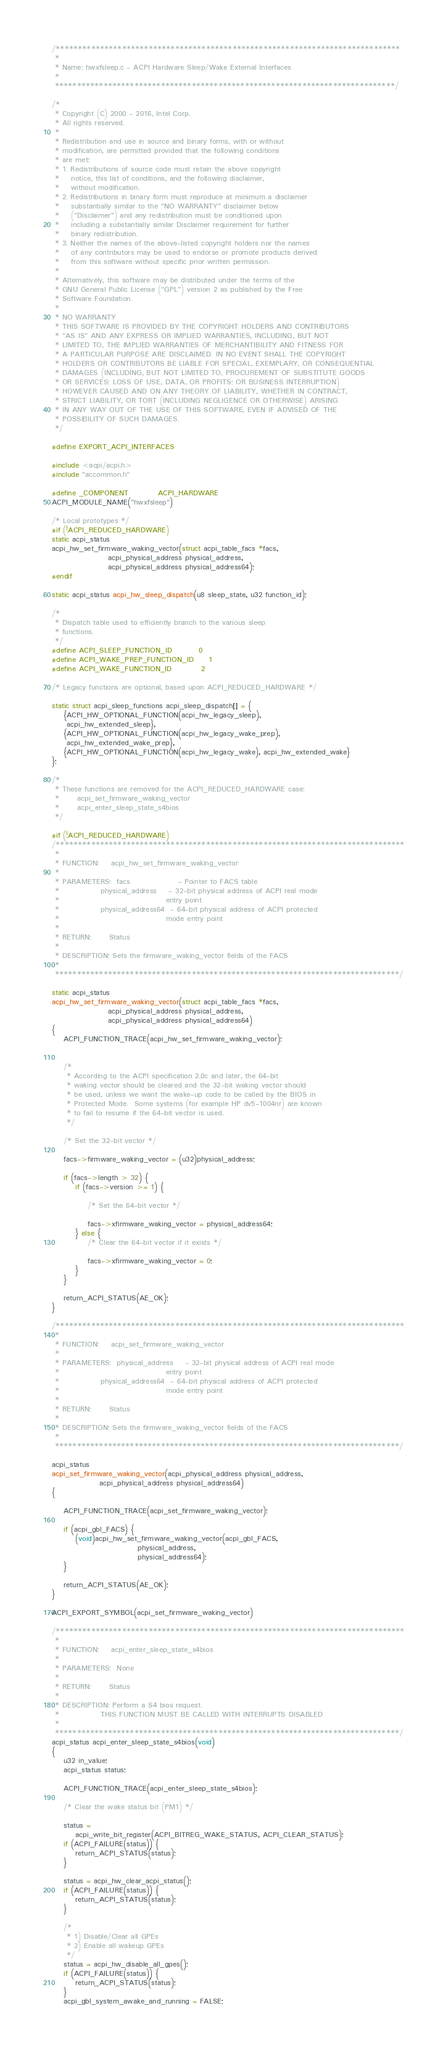<code> <loc_0><loc_0><loc_500><loc_500><_C_>/******************************************************************************
 *
 * Name: hwxfsleep.c - ACPI Hardware Sleep/Wake External Interfaces
 *
 *****************************************************************************/

/*
 * Copyright (C) 2000 - 2016, Intel Corp.
 * All rights reserved.
 *
 * Redistribution and use in source and binary forms, with or without
 * modification, are permitted provided that the following conditions
 * are met:
 * 1. Redistributions of source code must retain the above copyright
 *    notice, this list of conditions, and the following disclaimer,
 *    without modification.
 * 2. Redistributions in binary form must reproduce at minimum a disclaimer
 *    substantially similar to the "NO WARRANTY" disclaimer below
 *    ("Disclaimer") and any redistribution must be conditioned upon
 *    including a substantially similar Disclaimer requirement for further
 *    binary redistribution.
 * 3. Neither the names of the above-listed copyright holders nor the names
 *    of any contributors may be used to endorse or promote products derived
 *    from this software without specific prior written permission.
 *
 * Alternatively, this software may be distributed under the terms of the
 * GNU General Public License ("GPL") version 2 as published by the Free
 * Software Foundation.
 *
 * NO WARRANTY
 * THIS SOFTWARE IS PROVIDED BY THE COPYRIGHT HOLDERS AND CONTRIBUTORS
 * "AS IS" AND ANY EXPRESS OR IMPLIED WARRANTIES, INCLUDING, BUT NOT
 * LIMITED TO, THE IMPLIED WARRANTIES OF MERCHANTIBILITY AND FITNESS FOR
 * A PARTICULAR PURPOSE ARE DISCLAIMED. IN NO EVENT SHALL THE COPYRIGHT
 * HOLDERS OR CONTRIBUTORS BE LIABLE FOR SPECIAL, EXEMPLARY, OR CONSEQUENTIAL
 * DAMAGES (INCLUDING, BUT NOT LIMITED TO, PROCUREMENT OF SUBSTITUTE GOODS
 * OR SERVICES; LOSS OF USE, DATA, OR PROFITS; OR BUSINESS INTERRUPTION)
 * HOWEVER CAUSED AND ON ANY THEORY OF LIABILITY, WHETHER IN CONTRACT,
 * STRICT LIABILITY, OR TORT (INCLUDING NEGLIGENCE OR OTHERWISE) ARISING
 * IN ANY WAY OUT OF THE USE OF THIS SOFTWARE, EVEN IF ADVISED OF THE
 * POSSIBILITY OF SUCH DAMAGES.
 */

#define EXPORT_ACPI_INTERFACES

#include <acpi/acpi.h>
#include "accommon.h"

#define _COMPONENT          ACPI_HARDWARE
ACPI_MODULE_NAME("hwxfsleep")

/* Local prototypes */
#if (!ACPI_REDUCED_HARDWARE)
static acpi_status
acpi_hw_set_firmware_waking_vector(struct acpi_table_facs *facs,
				   acpi_physical_address physical_address,
				   acpi_physical_address physical_address64);
#endif

static acpi_status acpi_hw_sleep_dispatch(u8 sleep_state, u32 function_id);

/*
 * Dispatch table used to efficiently branch to the various sleep
 * functions.
 */
#define ACPI_SLEEP_FUNCTION_ID         0
#define ACPI_WAKE_PREP_FUNCTION_ID     1
#define ACPI_WAKE_FUNCTION_ID          2

/* Legacy functions are optional, based upon ACPI_REDUCED_HARDWARE */

static struct acpi_sleep_functions acpi_sleep_dispatch[] = {
	{ACPI_HW_OPTIONAL_FUNCTION(acpi_hw_legacy_sleep),
	 acpi_hw_extended_sleep},
	{ACPI_HW_OPTIONAL_FUNCTION(acpi_hw_legacy_wake_prep),
	 acpi_hw_extended_wake_prep},
	{ACPI_HW_OPTIONAL_FUNCTION(acpi_hw_legacy_wake), acpi_hw_extended_wake}
};

/*
 * These functions are removed for the ACPI_REDUCED_HARDWARE case:
 *      acpi_set_firmware_waking_vector
 *      acpi_enter_sleep_state_s4bios
 */

#if (!ACPI_REDUCED_HARDWARE)
/*******************************************************************************
 *
 * FUNCTION:    acpi_hw_set_firmware_waking_vector
 *
 * PARAMETERS:  facs                - Pointer to FACS table
 *              physical_address    - 32-bit physical address of ACPI real mode
 *                                    entry point
 *              physical_address64  - 64-bit physical address of ACPI protected
 *                                    mode entry point
 *
 * RETURN:      Status
 *
 * DESCRIPTION: Sets the firmware_waking_vector fields of the FACS
 *
 ******************************************************************************/

static acpi_status
acpi_hw_set_firmware_waking_vector(struct acpi_table_facs *facs,
				   acpi_physical_address physical_address,
				   acpi_physical_address physical_address64)
{
	ACPI_FUNCTION_TRACE(acpi_hw_set_firmware_waking_vector);


	/*
	 * According to the ACPI specification 2.0c and later, the 64-bit
	 * waking vector should be cleared and the 32-bit waking vector should
	 * be used, unless we want the wake-up code to be called by the BIOS in
	 * Protected Mode.  Some systems (for example HP dv5-1004nr) are known
	 * to fail to resume if the 64-bit vector is used.
	 */

	/* Set the 32-bit vector */

	facs->firmware_waking_vector = (u32)physical_address;

	if (facs->length > 32) {
		if (facs->version >= 1) {

			/* Set the 64-bit vector */

			facs->xfirmware_waking_vector = physical_address64;
		} else {
			/* Clear the 64-bit vector if it exists */

			facs->xfirmware_waking_vector = 0;
		}
	}

	return_ACPI_STATUS(AE_OK);
}

/*******************************************************************************
 *
 * FUNCTION:    acpi_set_firmware_waking_vector
 *
 * PARAMETERS:  physical_address    - 32-bit physical address of ACPI real mode
 *                                    entry point
 *              physical_address64  - 64-bit physical address of ACPI protected
 *                                    mode entry point
 *
 * RETURN:      Status
 *
 * DESCRIPTION: Sets the firmware_waking_vector fields of the FACS
 *
 ******************************************************************************/

acpi_status
acpi_set_firmware_waking_vector(acpi_physical_address physical_address,
				acpi_physical_address physical_address64)
{

	ACPI_FUNCTION_TRACE(acpi_set_firmware_waking_vector);

	if (acpi_gbl_FACS) {
		(void)acpi_hw_set_firmware_waking_vector(acpi_gbl_FACS,
							 physical_address,
							 physical_address64);
	}

	return_ACPI_STATUS(AE_OK);
}

ACPI_EXPORT_SYMBOL(acpi_set_firmware_waking_vector)

/*******************************************************************************
 *
 * FUNCTION:    acpi_enter_sleep_state_s4bios
 *
 * PARAMETERS:  None
 *
 * RETURN:      Status
 *
 * DESCRIPTION: Perform a S4 bios request.
 *              THIS FUNCTION MUST BE CALLED WITH INTERRUPTS DISABLED
 *
 ******************************************************************************/
acpi_status acpi_enter_sleep_state_s4bios(void)
{
	u32 in_value;
	acpi_status status;

	ACPI_FUNCTION_TRACE(acpi_enter_sleep_state_s4bios);

	/* Clear the wake status bit (PM1) */

	status =
	    acpi_write_bit_register(ACPI_BITREG_WAKE_STATUS, ACPI_CLEAR_STATUS);
	if (ACPI_FAILURE(status)) {
		return_ACPI_STATUS(status);
	}

	status = acpi_hw_clear_acpi_status();
	if (ACPI_FAILURE(status)) {
		return_ACPI_STATUS(status);
	}

	/*
	 * 1) Disable/Clear all GPEs
	 * 2) Enable all wakeup GPEs
	 */
	status = acpi_hw_disable_all_gpes();
	if (ACPI_FAILURE(status)) {
		return_ACPI_STATUS(status);
	}
	acpi_gbl_system_awake_and_running = FALSE;
</code> 